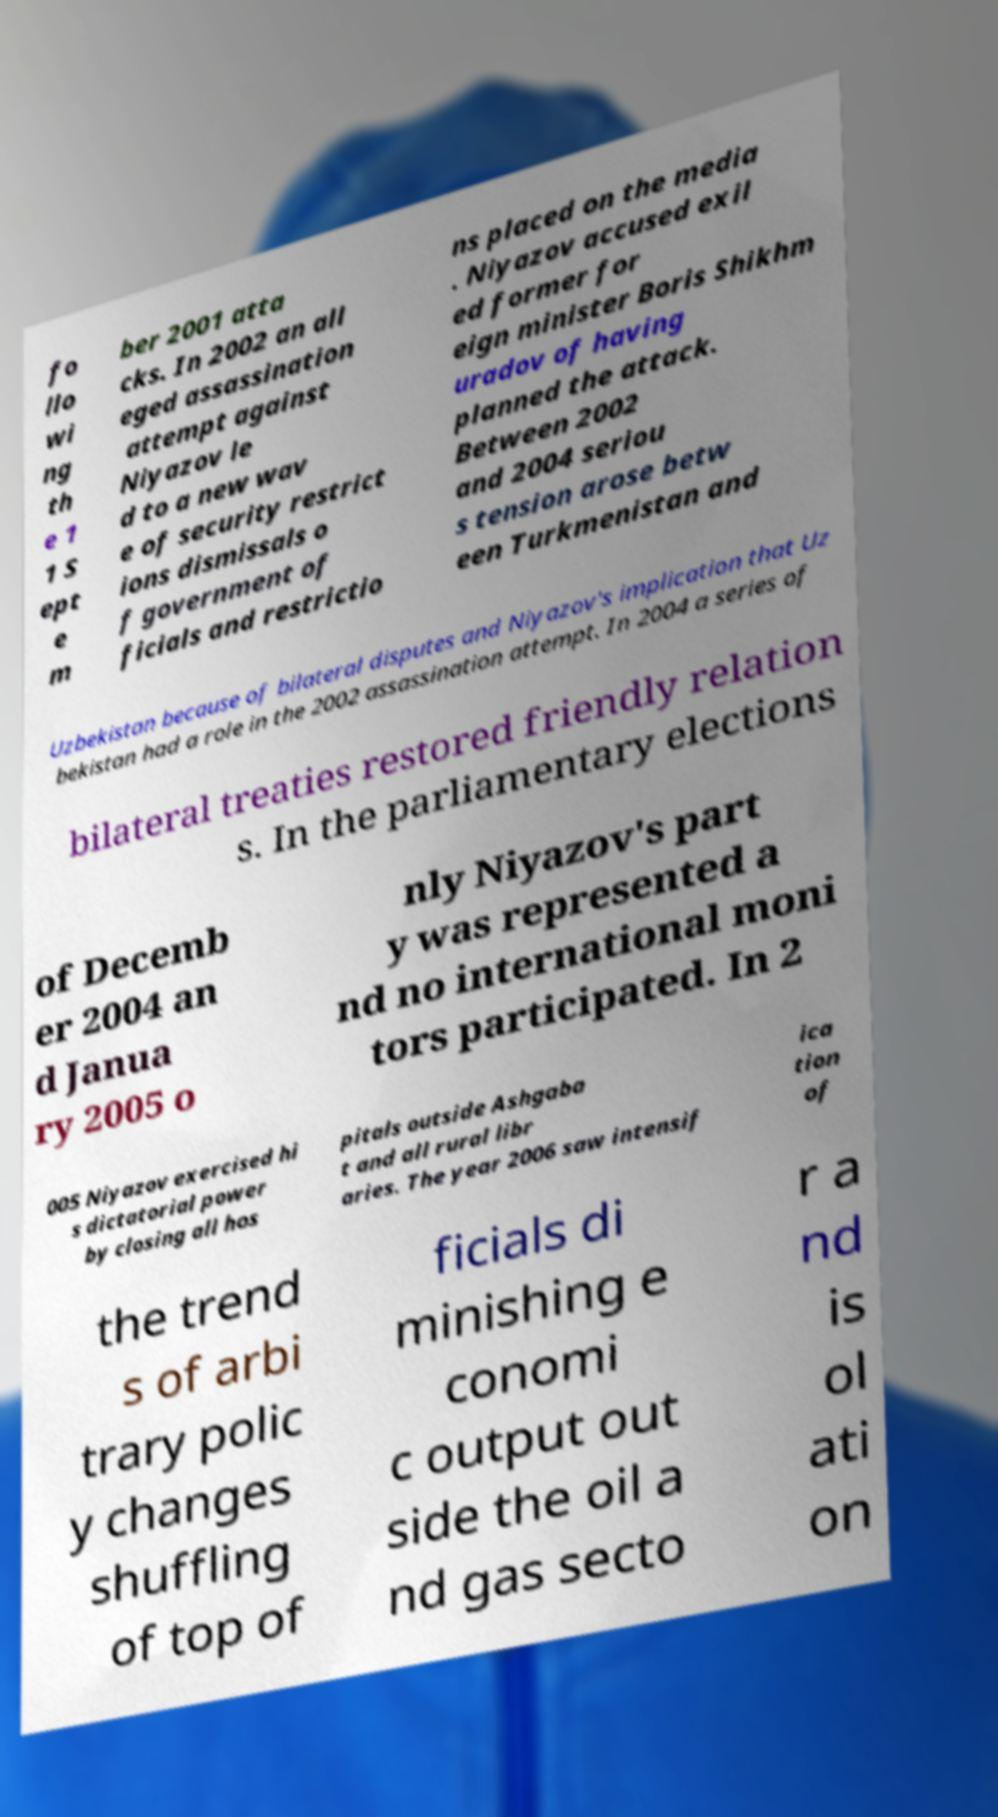I need the written content from this picture converted into text. Can you do that? fo llo wi ng th e 1 1 S ept e m ber 2001 atta cks. In 2002 an all eged assassination attempt against Niyazov le d to a new wav e of security restrict ions dismissals o f government of ficials and restrictio ns placed on the media . Niyazov accused exil ed former for eign minister Boris Shikhm uradov of having planned the attack. Between 2002 and 2004 seriou s tension arose betw een Turkmenistan and Uzbekistan because of bilateral disputes and Niyazov's implication that Uz bekistan had a role in the 2002 assassination attempt. In 2004 a series of bilateral treaties restored friendly relation s. In the parliamentary elections of Decemb er 2004 an d Janua ry 2005 o nly Niyazov's part y was represented a nd no international moni tors participated. In 2 005 Niyazov exercised hi s dictatorial power by closing all hos pitals outside Ashgaba t and all rural libr aries. The year 2006 saw intensif ica tion of the trend s of arbi trary polic y changes shuffling of top of ficials di minishing e conomi c output out side the oil a nd gas secto r a nd is ol ati on 